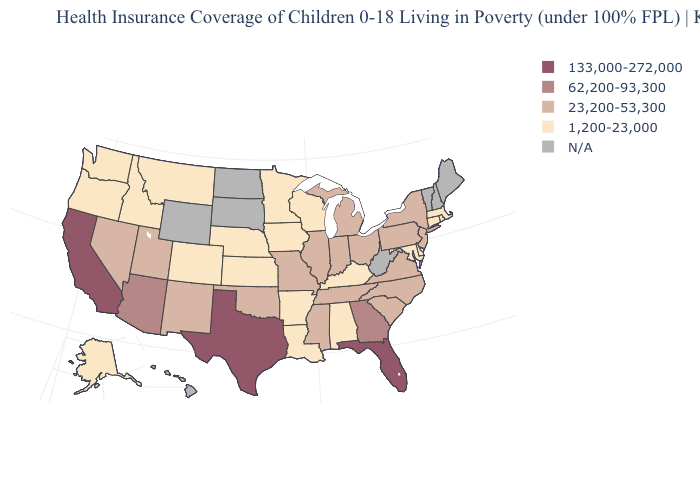How many symbols are there in the legend?
Keep it brief. 5. What is the value of Maryland?
Answer briefly. 1,200-23,000. What is the value of Georgia?
Give a very brief answer. 62,200-93,300. What is the value of South Dakota?
Answer briefly. N/A. Name the states that have a value in the range 1,200-23,000?
Give a very brief answer. Alabama, Alaska, Arkansas, Colorado, Connecticut, Delaware, Idaho, Iowa, Kansas, Kentucky, Louisiana, Maryland, Massachusetts, Minnesota, Montana, Nebraska, Oregon, Rhode Island, Washington, Wisconsin. Name the states that have a value in the range 23,200-53,300?
Give a very brief answer. Illinois, Indiana, Michigan, Mississippi, Missouri, Nevada, New Jersey, New Mexico, New York, North Carolina, Ohio, Oklahoma, Pennsylvania, South Carolina, Tennessee, Utah, Virginia. Among the states that border Virginia , does Maryland have the highest value?
Write a very short answer. No. What is the lowest value in the USA?
Quick response, please. 1,200-23,000. What is the highest value in states that border Pennsylvania?
Quick response, please. 23,200-53,300. Does Indiana have the lowest value in the MidWest?
Give a very brief answer. No. What is the highest value in the USA?
Concise answer only. 133,000-272,000. Name the states that have a value in the range 62,200-93,300?
Give a very brief answer. Arizona, Georgia. Does Texas have the highest value in the South?
Concise answer only. Yes. Name the states that have a value in the range N/A?
Concise answer only. Hawaii, Maine, New Hampshire, North Dakota, South Dakota, Vermont, West Virginia, Wyoming. Does Missouri have the lowest value in the MidWest?
Be succinct. No. 